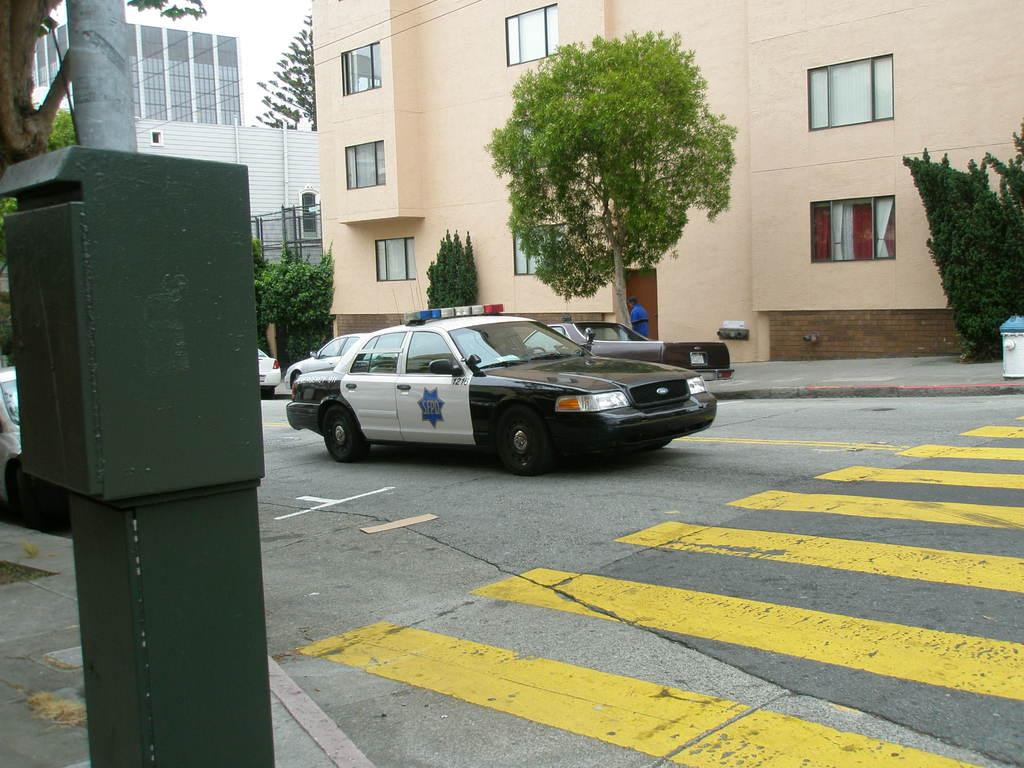What type of vehicles can be seen on the road in the image? There are cars on the road in the image. What structures are visible behind the cars? Buildings are visible behind the cars. What type of vegetation is present in the image? Trees are present in the image. Where is the green-colored letterbox located in the image? The green-colored letterbox is on the left side of the image. Can you see any snails crawling on the trees in the image? There are no snails visible in the image; only cars, buildings, trees, and a green-colored letterbox are present. What type of pets can be seen playing with the cars in the image? There are no pets visible in the image; only cars, buildings, trees, and a green-colored letterbox are present. 